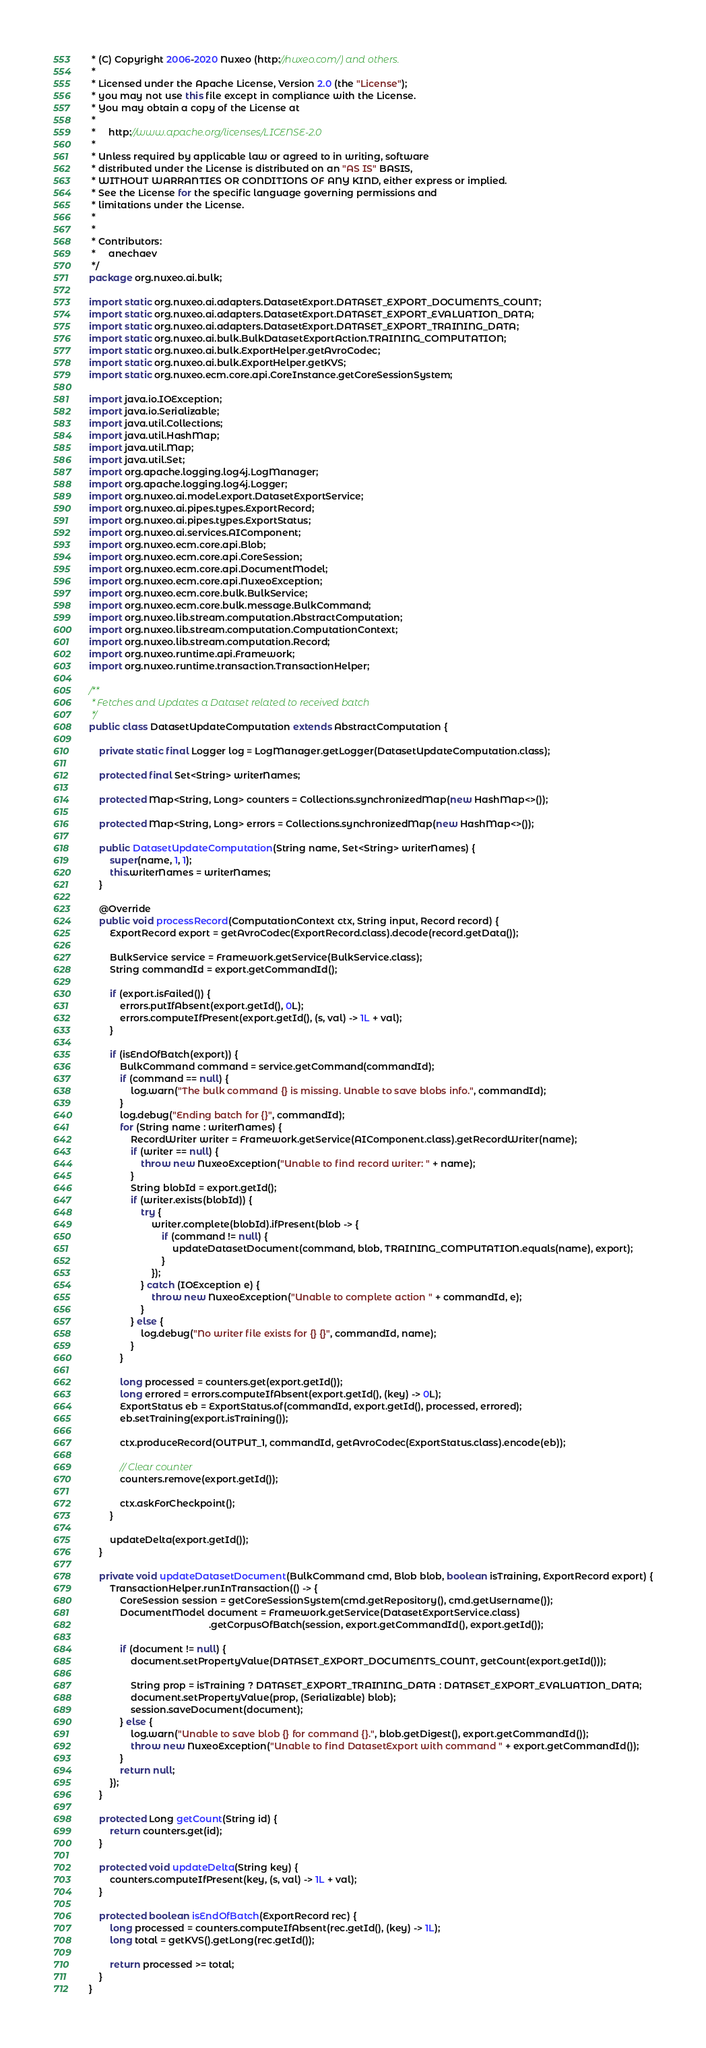<code> <loc_0><loc_0><loc_500><loc_500><_Java_> * (C) Copyright 2006-2020 Nuxeo (http://nuxeo.com/) and others.
 *
 * Licensed under the Apache License, Version 2.0 (the "License");
 * you may not use this file except in compliance with the License.
 * You may obtain a copy of the License at
 *
 *     http://www.apache.org/licenses/LICENSE-2.0
 *
 * Unless required by applicable law or agreed to in writing, software
 * distributed under the License is distributed on an "AS IS" BASIS,
 * WITHOUT WARRANTIES OR CONDITIONS OF ANY KIND, either express or implied.
 * See the License for the specific language governing permissions and
 * limitations under the License.
 *
 *
 * Contributors:
 *     anechaev
 */
package org.nuxeo.ai.bulk;

import static org.nuxeo.ai.adapters.DatasetExport.DATASET_EXPORT_DOCUMENTS_COUNT;
import static org.nuxeo.ai.adapters.DatasetExport.DATASET_EXPORT_EVALUATION_DATA;
import static org.nuxeo.ai.adapters.DatasetExport.DATASET_EXPORT_TRAINING_DATA;
import static org.nuxeo.ai.bulk.BulkDatasetExportAction.TRAINING_COMPUTATION;
import static org.nuxeo.ai.bulk.ExportHelper.getAvroCodec;
import static org.nuxeo.ai.bulk.ExportHelper.getKVS;
import static org.nuxeo.ecm.core.api.CoreInstance.getCoreSessionSystem;

import java.io.IOException;
import java.io.Serializable;
import java.util.Collections;
import java.util.HashMap;
import java.util.Map;
import java.util.Set;
import org.apache.logging.log4j.LogManager;
import org.apache.logging.log4j.Logger;
import org.nuxeo.ai.model.export.DatasetExportService;
import org.nuxeo.ai.pipes.types.ExportRecord;
import org.nuxeo.ai.pipes.types.ExportStatus;
import org.nuxeo.ai.services.AIComponent;
import org.nuxeo.ecm.core.api.Blob;
import org.nuxeo.ecm.core.api.CoreSession;
import org.nuxeo.ecm.core.api.DocumentModel;
import org.nuxeo.ecm.core.api.NuxeoException;
import org.nuxeo.ecm.core.bulk.BulkService;
import org.nuxeo.ecm.core.bulk.message.BulkCommand;
import org.nuxeo.lib.stream.computation.AbstractComputation;
import org.nuxeo.lib.stream.computation.ComputationContext;
import org.nuxeo.lib.stream.computation.Record;
import org.nuxeo.runtime.api.Framework;
import org.nuxeo.runtime.transaction.TransactionHelper;

/**
 * Fetches and Updates a Dataset related to received batch
 */
public class DatasetUpdateComputation extends AbstractComputation {

    private static final Logger log = LogManager.getLogger(DatasetUpdateComputation.class);

    protected final Set<String> writerNames;

    protected Map<String, Long> counters = Collections.synchronizedMap(new HashMap<>());

    protected Map<String, Long> errors = Collections.synchronizedMap(new HashMap<>());

    public DatasetUpdateComputation(String name, Set<String> writerNames) {
        super(name, 1, 1);
        this.writerNames = writerNames;
    }

    @Override
    public void processRecord(ComputationContext ctx, String input, Record record) {
        ExportRecord export = getAvroCodec(ExportRecord.class).decode(record.getData());

        BulkService service = Framework.getService(BulkService.class);
        String commandId = export.getCommandId();

        if (export.isFailed()) {
            errors.putIfAbsent(export.getId(), 0L);
            errors.computeIfPresent(export.getId(), (s, val) -> 1L + val);
        }

        if (isEndOfBatch(export)) {
            BulkCommand command = service.getCommand(commandId);
            if (command == null) {
                log.warn("The bulk command {} is missing. Unable to save blobs info.", commandId);
            }
            log.debug("Ending batch for {}", commandId);
            for (String name : writerNames) {
                RecordWriter writer = Framework.getService(AIComponent.class).getRecordWriter(name);
                if (writer == null) {
                    throw new NuxeoException("Unable to find record writer: " + name);
                }
                String blobId = export.getId();
                if (writer.exists(blobId)) {
                    try {
                        writer.complete(blobId).ifPresent(blob -> {
                            if (command != null) {
                                updateDatasetDocument(command, blob, TRAINING_COMPUTATION.equals(name), export);
                            }
                        });
                    } catch (IOException e) {
                        throw new NuxeoException("Unable to complete action " + commandId, e);
                    }
                } else {
                    log.debug("No writer file exists for {} {}", commandId, name);
                }
            }

            long processed = counters.get(export.getId());
            long errored = errors.computeIfAbsent(export.getId(), (key) -> 0L);
            ExportStatus eb = ExportStatus.of(commandId, export.getId(), processed, errored);
            eb.setTraining(export.isTraining());

            ctx.produceRecord(OUTPUT_1, commandId, getAvroCodec(ExportStatus.class).encode(eb));

            // Clear counter
            counters.remove(export.getId());

            ctx.askForCheckpoint();
        }

        updateDelta(export.getId());
    }

    private void updateDatasetDocument(BulkCommand cmd, Blob blob, boolean isTraining, ExportRecord export) {
        TransactionHelper.runInTransaction(() -> {
            CoreSession session = getCoreSessionSystem(cmd.getRepository(), cmd.getUsername());
            DocumentModel document = Framework.getService(DatasetExportService.class)
                                              .getCorpusOfBatch(session, export.getCommandId(), export.getId());

            if (document != null) {
                document.setPropertyValue(DATASET_EXPORT_DOCUMENTS_COUNT, getCount(export.getId()));

                String prop = isTraining ? DATASET_EXPORT_TRAINING_DATA : DATASET_EXPORT_EVALUATION_DATA;
                document.setPropertyValue(prop, (Serializable) blob);
                session.saveDocument(document);
            } else {
                log.warn("Unable to save blob {} for command {}.", blob.getDigest(), export.getCommandId());
                throw new NuxeoException("Unable to find DatasetExport with command " + export.getCommandId());
            }
            return null;
        });
    }

    protected Long getCount(String id) {
        return counters.get(id);
    }

    protected void updateDelta(String key) {
        counters.computeIfPresent(key, (s, val) -> 1L + val);
    }

    protected boolean isEndOfBatch(ExportRecord rec) {
        long processed = counters.computeIfAbsent(rec.getId(), (key) -> 1L);
        long total = getKVS().getLong(rec.getId());

        return processed >= total;
    }
}
</code> 